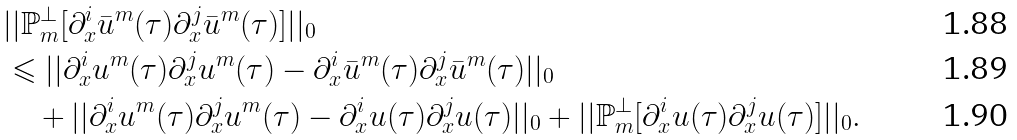<formula> <loc_0><loc_0><loc_500><loc_500>& | | \mathbb { P } ^ { \bot } _ { m } [ \partial ^ { i } _ { x } \bar { u } ^ { m } ( \tau ) \partial ^ { j } _ { x } \bar { u } ^ { m } ( \tau ) ] | | _ { 0 } \\ & \leqslant | | \partial ^ { i } _ { x } u ^ { m } ( \tau ) \partial ^ { j } _ { x } u ^ { m } ( \tau ) - \partial ^ { i } _ { x } \bar { u } ^ { m } ( \tau ) \partial ^ { j } _ { x } \bar { u } ^ { m } ( \tau ) | | _ { 0 } \\ & \quad + | | \partial ^ { i } _ { x } u ^ { m } ( \tau ) \partial ^ { j } _ { x } u ^ { m } ( \tau ) - \partial ^ { i } _ { x } u ( \tau ) \partial ^ { j } _ { x } u ( \tau ) | | _ { 0 } + | | \mathbb { P } _ { m } ^ { \bot } [ \partial ^ { i } _ { x } u ( \tau ) \partial ^ { j } _ { x } u ( \tau ) ] | | _ { 0 } .</formula> 